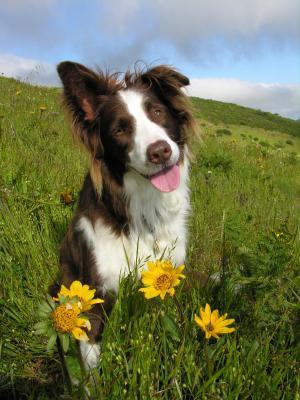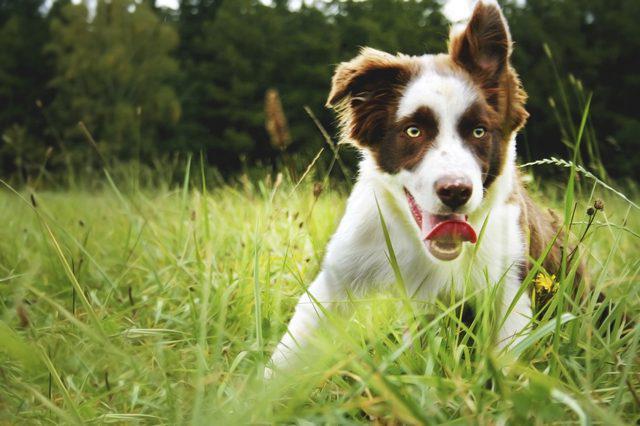The first image is the image on the left, the second image is the image on the right. For the images displayed, is the sentence "There are at least four dogs in total." factually correct? Answer yes or no. No. The first image is the image on the left, the second image is the image on the right. For the images displayed, is the sentence "in the left image there is a do with the left ear up and the right ear down" factually correct? Answer yes or no. Yes. 